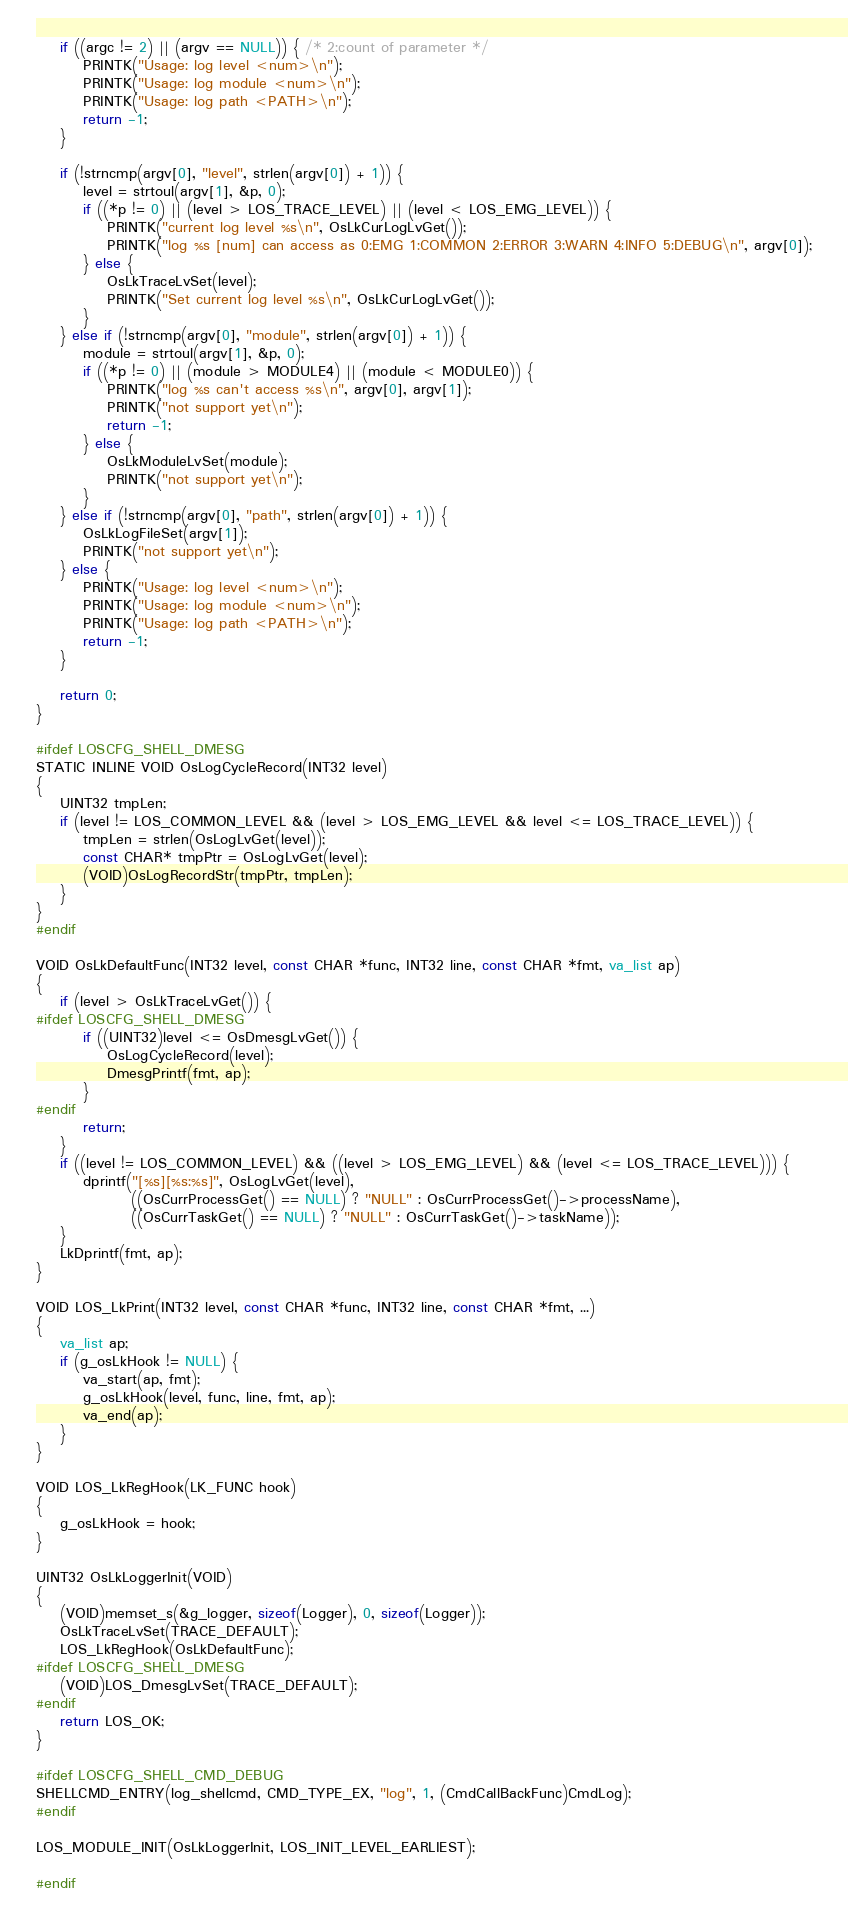Convert code to text. <code><loc_0><loc_0><loc_500><loc_500><_C_>    if ((argc != 2) || (argv == NULL)) { /* 2:count of parameter */
        PRINTK("Usage: log level <num>\n");
        PRINTK("Usage: log module <num>\n");
        PRINTK("Usage: log path <PATH>\n");
        return -1;
    }

    if (!strncmp(argv[0], "level", strlen(argv[0]) + 1)) {
        level = strtoul(argv[1], &p, 0);
        if ((*p != 0) || (level > LOS_TRACE_LEVEL) || (level < LOS_EMG_LEVEL)) {
            PRINTK("current log level %s\n", OsLkCurLogLvGet());
            PRINTK("log %s [num] can access as 0:EMG 1:COMMON 2:ERROR 3:WARN 4:INFO 5:DEBUG\n", argv[0]);
        } else {
            OsLkTraceLvSet(level);
            PRINTK("Set current log level %s\n", OsLkCurLogLvGet());
        }
    } else if (!strncmp(argv[0], "module", strlen(argv[0]) + 1)) {
        module = strtoul(argv[1], &p, 0);
        if ((*p != 0) || (module > MODULE4) || (module < MODULE0)) {
            PRINTK("log %s can't access %s\n", argv[0], argv[1]);
            PRINTK("not support yet\n");
            return -1;
        } else {
            OsLkModuleLvSet(module);
            PRINTK("not support yet\n");
        }
    } else if (!strncmp(argv[0], "path", strlen(argv[0]) + 1)) {
        OsLkLogFileSet(argv[1]);
        PRINTK("not support yet\n");
    } else {
        PRINTK("Usage: log level <num>\n");
        PRINTK("Usage: log module <num>\n");
        PRINTK("Usage: log path <PATH>\n");
        return -1;
    }

    return 0;
}

#ifdef LOSCFG_SHELL_DMESG
STATIC INLINE VOID OsLogCycleRecord(INT32 level)
{
    UINT32 tmpLen;
    if (level != LOS_COMMON_LEVEL && (level > LOS_EMG_LEVEL && level <= LOS_TRACE_LEVEL)) {
        tmpLen = strlen(OsLogLvGet(level));
        const CHAR* tmpPtr = OsLogLvGet(level);
        (VOID)OsLogRecordStr(tmpPtr, tmpLen);
    }
}
#endif

VOID OsLkDefaultFunc(INT32 level, const CHAR *func, INT32 line, const CHAR *fmt, va_list ap)
{
    if (level > OsLkTraceLvGet()) {
#ifdef LOSCFG_SHELL_DMESG
        if ((UINT32)level <= OsDmesgLvGet()) {
            OsLogCycleRecord(level);
            DmesgPrintf(fmt, ap);
        }
#endif
        return;
    }
    if ((level != LOS_COMMON_LEVEL) && ((level > LOS_EMG_LEVEL) && (level <= LOS_TRACE_LEVEL))) {
        dprintf("[%s][%s:%s]", OsLogLvGet(level),
                ((OsCurrProcessGet() == NULL) ? "NULL" : OsCurrProcessGet()->processName),
                ((OsCurrTaskGet() == NULL) ? "NULL" : OsCurrTaskGet()->taskName));
    }
    LkDprintf(fmt, ap);
}

VOID LOS_LkPrint(INT32 level, const CHAR *func, INT32 line, const CHAR *fmt, ...)
{
    va_list ap;
    if (g_osLkHook != NULL) {
        va_start(ap, fmt);
        g_osLkHook(level, func, line, fmt, ap);
        va_end(ap);
    }
}

VOID LOS_LkRegHook(LK_FUNC hook)
{
    g_osLkHook = hook;
}

UINT32 OsLkLoggerInit(VOID)
{
    (VOID)memset_s(&g_logger, sizeof(Logger), 0, sizeof(Logger));
    OsLkTraceLvSet(TRACE_DEFAULT);
    LOS_LkRegHook(OsLkDefaultFunc);
#ifdef LOSCFG_SHELL_DMESG
    (VOID)LOS_DmesgLvSet(TRACE_DEFAULT);
#endif
    return LOS_OK;
}

#ifdef LOSCFG_SHELL_CMD_DEBUG
SHELLCMD_ENTRY(log_shellcmd, CMD_TYPE_EX, "log", 1, (CmdCallBackFunc)CmdLog);
#endif

LOS_MODULE_INIT(OsLkLoggerInit, LOS_INIT_LEVEL_EARLIEST);

#endif
</code> 